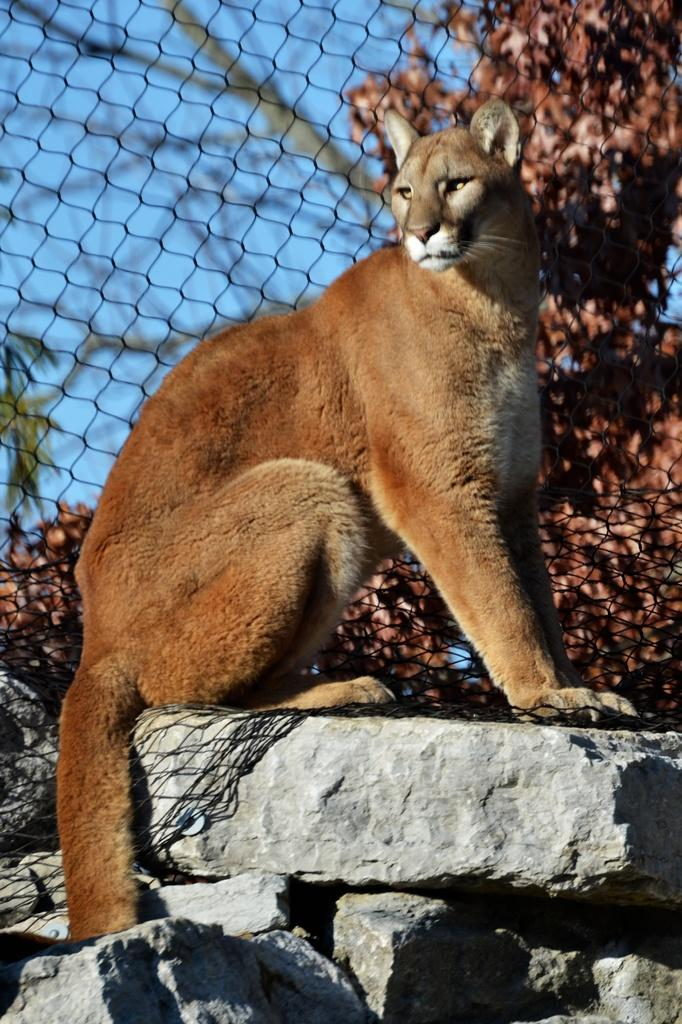What animal is the main subject of the image? There is a lioness in the image. What is the lioness standing on? The lioness is on rocks in the image. What type of barrier is visible in the image? There is a net fence in the image. What type of vegetation can be seen in the image? There are trees in the image. What type of leaf is the lioness holding in her mouth in the image? There is no leaf present in the image; the lioness is not holding anything in her mouth. 